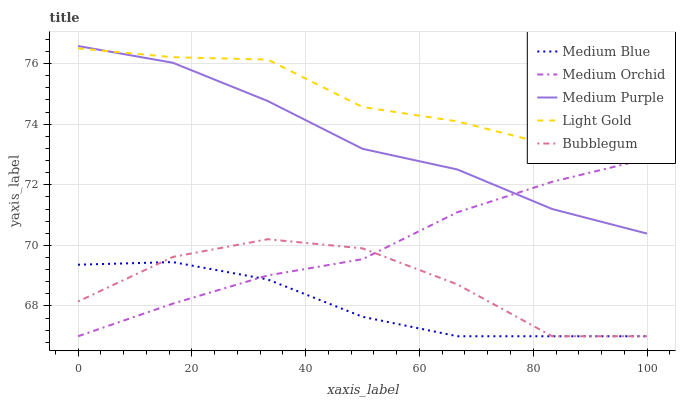Does Medium Blue have the minimum area under the curve?
Answer yes or no. Yes. Does Light Gold have the maximum area under the curve?
Answer yes or no. Yes. Does Medium Orchid have the minimum area under the curve?
Answer yes or no. No. Does Medium Orchid have the maximum area under the curve?
Answer yes or no. No. Is Medium Orchid the smoothest?
Answer yes or no. Yes. Is Bubblegum the roughest?
Answer yes or no. Yes. Is Light Gold the smoothest?
Answer yes or no. No. Is Light Gold the roughest?
Answer yes or no. No. Does Medium Orchid have the lowest value?
Answer yes or no. Yes. Does Light Gold have the lowest value?
Answer yes or no. No. Does Medium Purple have the highest value?
Answer yes or no. Yes. Does Light Gold have the highest value?
Answer yes or no. No. Is Bubblegum less than Light Gold?
Answer yes or no. Yes. Is Light Gold greater than Medium Blue?
Answer yes or no. Yes. Does Medium Orchid intersect Medium Blue?
Answer yes or no. Yes. Is Medium Orchid less than Medium Blue?
Answer yes or no. No. Is Medium Orchid greater than Medium Blue?
Answer yes or no. No. Does Bubblegum intersect Light Gold?
Answer yes or no. No. 